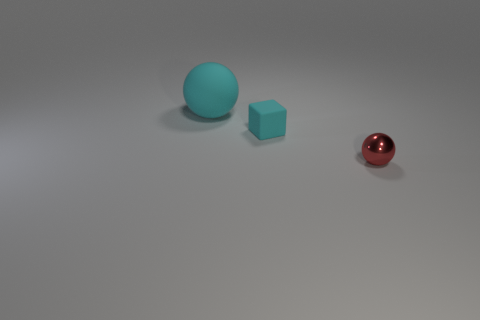Add 2 tiny cyan matte cubes. How many objects exist? 5 Subtract all cubes. How many objects are left? 2 Subtract 0 green balls. How many objects are left? 3 Subtract all cyan blocks. Subtract all spheres. How many objects are left? 0 Add 3 shiny objects. How many shiny objects are left? 4 Add 3 tiny matte objects. How many tiny matte objects exist? 4 